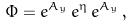Convert formula to latex. <formula><loc_0><loc_0><loc_500><loc_500>\Phi = e ^ { A _ { y } } \, e ^ { \eta } \, e ^ { A _ { y } } \, ,</formula> 